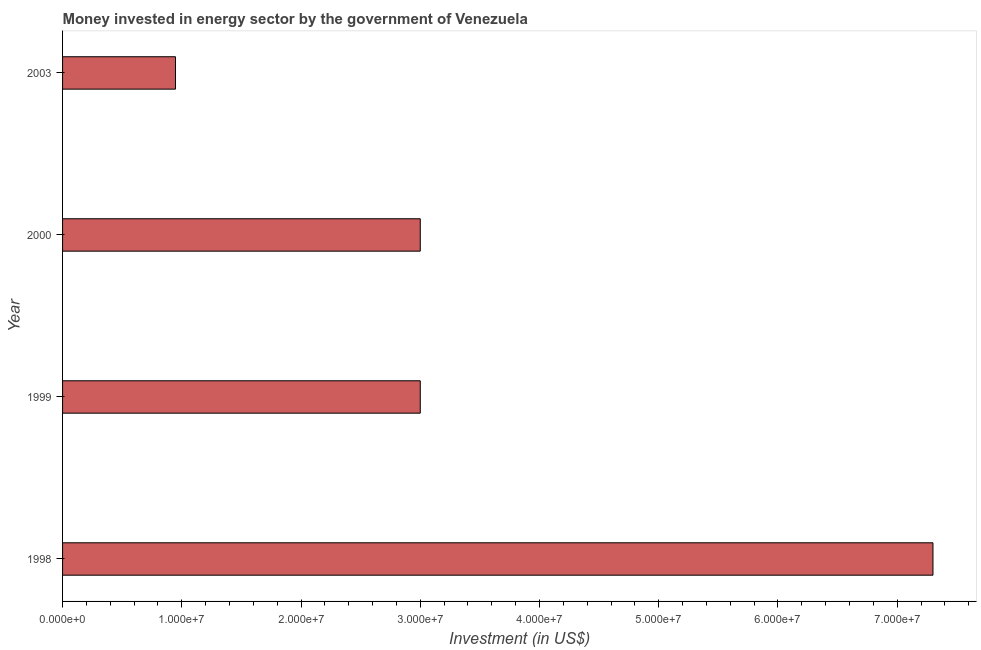Does the graph contain any zero values?
Make the answer very short. No. What is the title of the graph?
Ensure brevity in your answer.  Money invested in energy sector by the government of Venezuela. What is the label or title of the X-axis?
Your answer should be very brief. Investment (in US$). What is the investment in energy in 2003?
Your answer should be very brief. 9.47e+06. Across all years, what is the maximum investment in energy?
Provide a short and direct response. 7.30e+07. Across all years, what is the minimum investment in energy?
Provide a succinct answer. 9.47e+06. In which year was the investment in energy maximum?
Offer a terse response. 1998. In which year was the investment in energy minimum?
Provide a succinct answer. 2003. What is the sum of the investment in energy?
Your response must be concise. 1.42e+08. What is the difference between the investment in energy in 2000 and 2003?
Ensure brevity in your answer.  2.05e+07. What is the average investment in energy per year?
Offer a terse response. 3.56e+07. What is the median investment in energy?
Your answer should be compact. 3.00e+07. In how many years, is the investment in energy greater than 74000000 US$?
Provide a succinct answer. 0. Do a majority of the years between 1998 and 2003 (inclusive) have investment in energy greater than 32000000 US$?
Give a very brief answer. No. What is the ratio of the investment in energy in 1999 to that in 2003?
Provide a short and direct response. 3.17. Is the investment in energy in 2000 less than that in 2003?
Make the answer very short. No. Is the difference between the investment in energy in 1998 and 2003 greater than the difference between any two years?
Offer a terse response. Yes. What is the difference between the highest and the second highest investment in energy?
Provide a succinct answer. 4.30e+07. What is the difference between the highest and the lowest investment in energy?
Ensure brevity in your answer.  6.35e+07. In how many years, is the investment in energy greater than the average investment in energy taken over all years?
Offer a terse response. 1. How many years are there in the graph?
Make the answer very short. 4. What is the difference between two consecutive major ticks on the X-axis?
Your response must be concise. 1.00e+07. Are the values on the major ticks of X-axis written in scientific E-notation?
Your response must be concise. Yes. What is the Investment (in US$) in 1998?
Your answer should be compact. 7.30e+07. What is the Investment (in US$) in 1999?
Ensure brevity in your answer.  3.00e+07. What is the Investment (in US$) of 2000?
Keep it short and to the point. 3.00e+07. What is the Investment (in US$) in 2003?
Your answer should be very brief. 9.47e+06. What is the difference between the Investment (in US$) in 1998 and 1999?
Keep it short and to the point. 4.30e+07. What is the difference between the Investment (in US$) in 1998 and 2000?
Keep it short and to the point. 4.30e+07. What is the difference between the Investment (in US$) in 1998 and 2003?
Your answer should be very brief. 6.35e+07. What is the difference between the Investment (in US$) in 1999 and 2000?
Your answer should be very brief. 0. What is the difference between the Investment (in US$) in 1999 and 2003?
Provide a succinct answer. 2.05e+07. What is the difference between the Investment (in US$) in 2000 and 2003?
Ensure brevity in your answer.  2.05e+07. What is the ratio of the Investment (in US$) in 1998 to that in 1999?
Make the answer very short. 2.43. What is the ratio of the Investment (in US$) in 1998 to that in 2000?
Offer a terse response. 2.43. What is the ratio of the Investment (in US$) in 1998 to that in 2003?
Keep it short and to the point. 7.71. What is the ratio of the Investment (in US$) in 1999 to that in 2000?
Provide a short and direct response. 1. What is the ratio of the Investment (in US$) in 1999 to that in 2003?
Offer a terse response. 3.17. What is the ratio of the Investment (in US$) in 2000 to that in 2003?
Give a very brief answer. 3.17. 